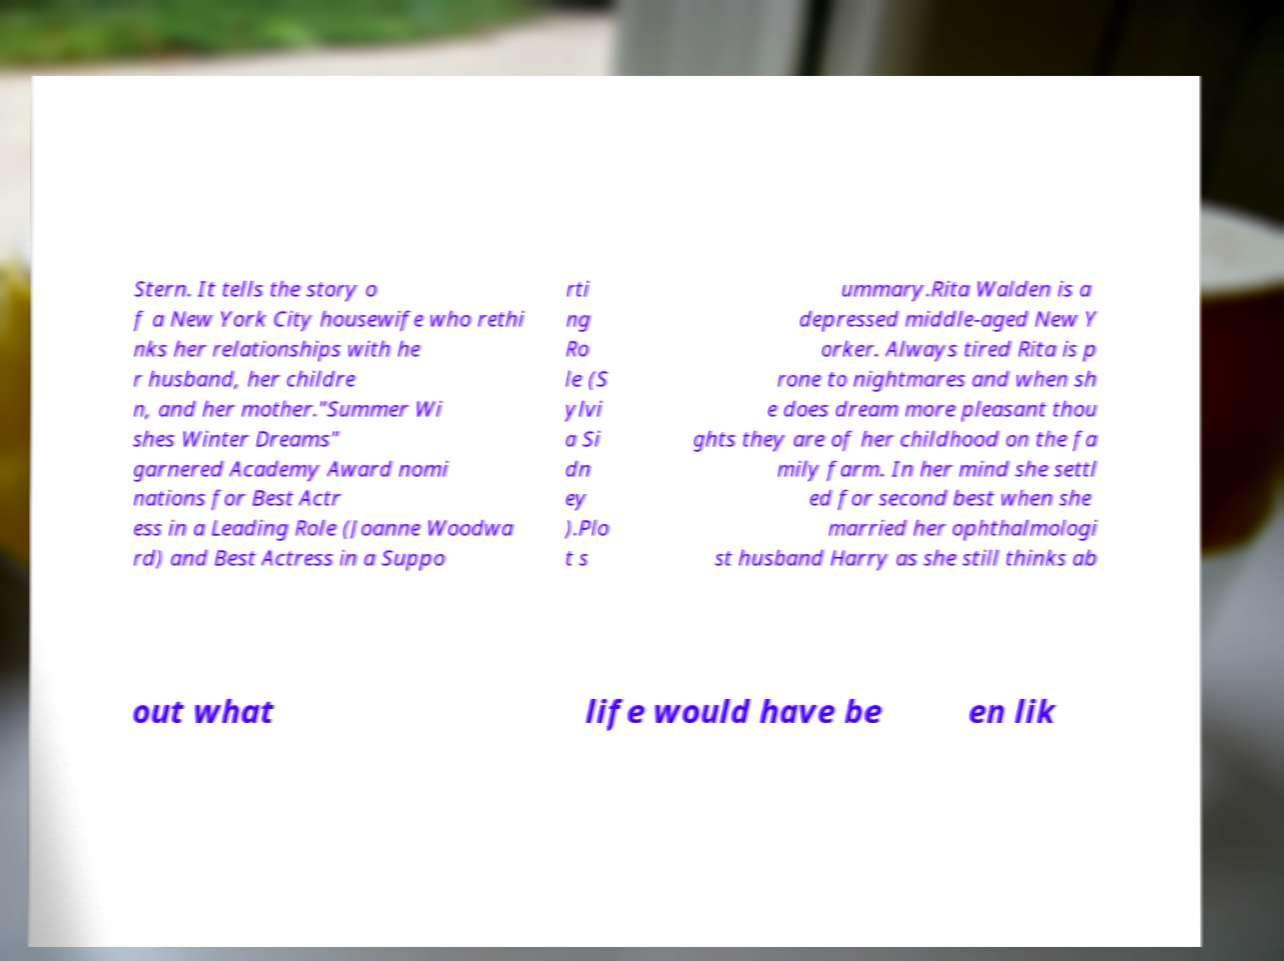Please read and relay the text visible in this image. What does it say? Stern. It tells the story o f a New York City housewife who rethi nks her relationships with he r husband, her childre n, and her mother."Summer Wi shes Winter Dreams" garnered Academy Award nomi nations for Best Actr ess in a Leading Role (Joanne Woodwa rd) and Best Actress in a Suppo rti ng Ro le (S ylvi a Si dn ey ).Plo t s ummary.Rita Walden is a depressed middle-aged New Y orker. Always tired Rita is p rone to nightmares and when sh e does dream more pleasant thou ghts they are of her childhood on the fa mily farm. In her mind she settl ed for second best when she married her ophthalmologi st husband Harry as she still thinks ab out what life would have be en lik 